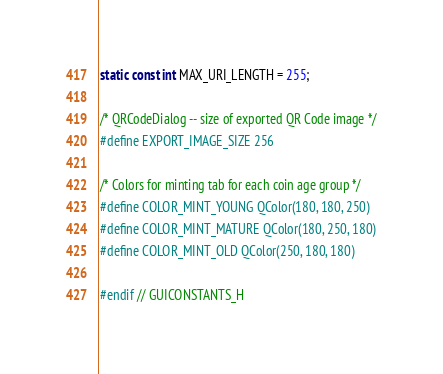<code> <loc_0><loc_0><loc_500><loc_500><_C_>static const int MAX_URI_LENGTH = 255;

/* QRCodeDialog -- size of exported QR Code image */
#define EXPORT_IMAGE_SIZE 256

/* Colors for minting tab for each coin age group */
#define COLOR_MINT_YOUNG QColor(180, 180, 250)
#define COLOR_MINT_MATURE QColor(180, 250, 180)
#define COLOR_MINT_OLD QColor(250, 180, 180)

#endif // GUICONSTANTS_H
</code> 